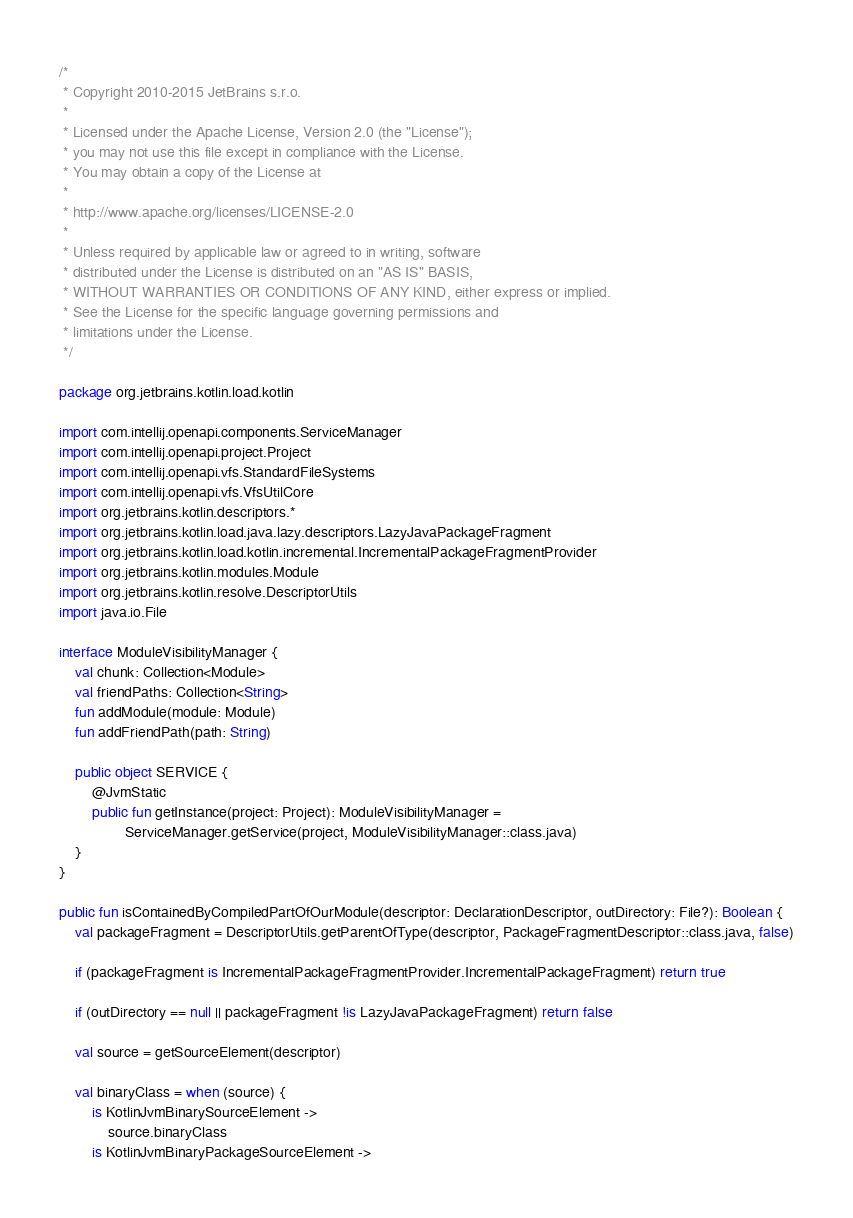<code> <loc_0><loc_0><loc_500><loc_500><_Kotlin_>/*
 * Copyright 2010-2015 JetBrains s.r.o.
 *
 * Licensed under the Apache License, Version 2.0 (the "License");
 * you may not use this file except in compliance with the License.
 * You may obtain a copy of the License at
 *
 * http://www.apache.org/licenses/LICENSE-2.0
 *
 * Unless required by applicable law or agreed to in writing, software
 * distributed under the License is distributed on an "AS IS" BASIS,
 * WITHOUT WARRANTIES OR CONDITIONS OF ANY KIND, either express or implied.
 * See the License for the specific language governing permissions and
 * limitations under the License.
 */

package org.jetbrains.kotlin.load.kotlin

import com.intellij.openapi.components.ServiceManager
import com.intellij.openapi.project.Project
import com.intellij.openapi.vfs.StandardFileSystems
import com.intellij.openapi.vfs.VfsUtilCore
import org.jetbrains.kotlin.descriptors.*
import org.jetbrains.kotlin.load.java.lazy.descriptors.LazyJavaPackageFragment
import org.jetbrains.kotlin.load.kotlin.incremental.IncrementalPackageFragmentProvider
import org.jetbrains.kotlin.modules.Module
import org.jetbrains.kotlin.resolve.DescriptorUtils
import java.io.File

interface ModuleVisibilityManager {
    val chunk: Collection<Module>
    val friendPaths: Collection<String>
    fun addModule(module: Module)
    fun addFriendPath(path: String)

    public object SERVICE {
        @JvmStatic
        public fun getInstance(project: Project): ModuleVisibilityManager =
                ServiceManager.getService(project, ModuleVisibilityManager::class.java)
    }
}

public fun isContainedByCompiledPartOfOurModule(descriptor: DeclarationDescriptor, outDirectory: File?): Boolean {
    val packageFragment = DescriptorUtils.getParentOfType(descriptor, PackageFragmentDescriptor::class.java, false)

    if (packageFragment is IncrementalPackageFragmentProvider.IncrementalPackageFragment) return true

    if (outDirectory == null || packageFragment !is LazyJavaPackageFragment) return false

    val source = getSourceElement(descriptor)

    val binaryClass = when (source) {
        is KotlinJvmBinarySourceElement ->
            source.binaryClass
        is KotlinJvmBinaryPackageSourceElement -></code> 